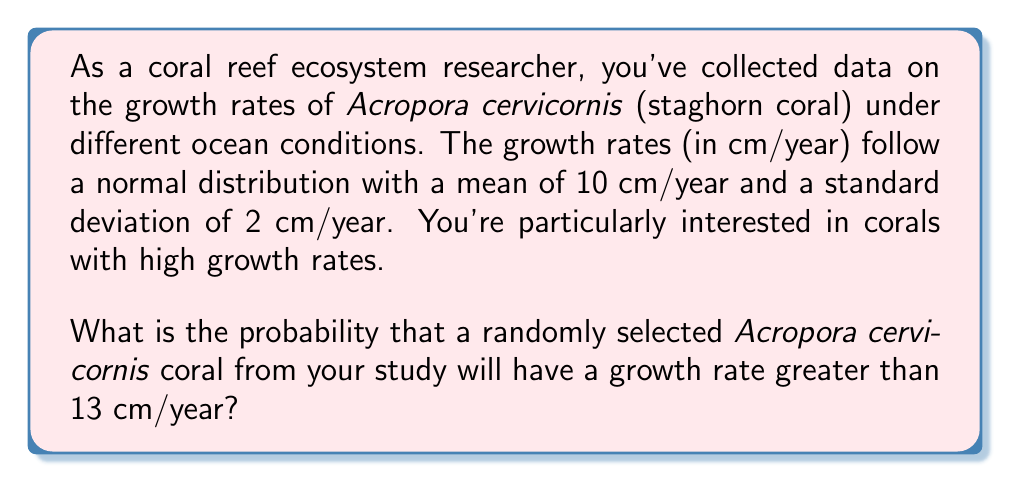Show me your answer to this math problem. To solve this problem, we need to use the properties of the normal distribution and the concept of z-scores.

Given:
- The growth rates follow a normal distribution
- Mean (μ) = 10 cm/year
- Standard deviation (σ) = 2 cm/year
- We want to find P(X > 13), where X is the growth rate

Steps:
1. Calculate the z-score for 13 cm/year:
   $$ z = \frac{x - μ}{σ} = \frac{13 - 10}{2} = 1.5 $$

2. The problem is now equivalent to finding P(Z > 1.5) where Z is the standard normal variable.

3. Using a standard normal table or calculator, we can find that:
   $$ P(Z < 1.5) ≈ 0.9332 $$

4. Since we want P(Z > 1.5), and the total probability is 1, we calculate:
   $$ P(Z > 1.5) = 1 - P(Z < 1.5) = 1 - 0.9332 = 0.0668 $$

5. Convert to a percentage:
   $$ 0.0668 × 100\% = 6.68\% $$
Answer: The probability that a randomly selected Acropora cervicornis coral from the study will have a growth rate greater than 13 cm/year is approximately 6.68%. 